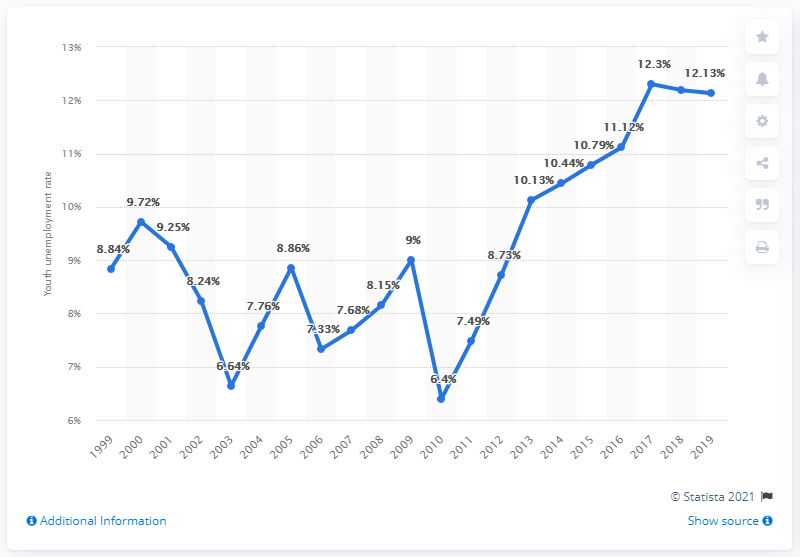Highlight a few significant elements in this photo. In 2019, the youth unemployment rate in Bangladesh was 12.13%. 